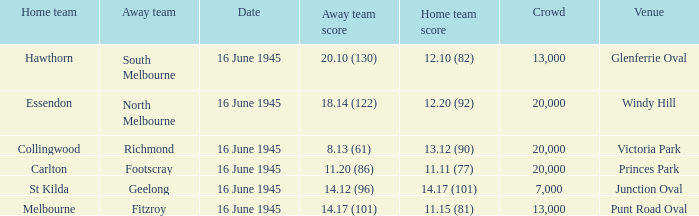What was the Home team score for the team that played South Melbourne? 12.10 (82). 